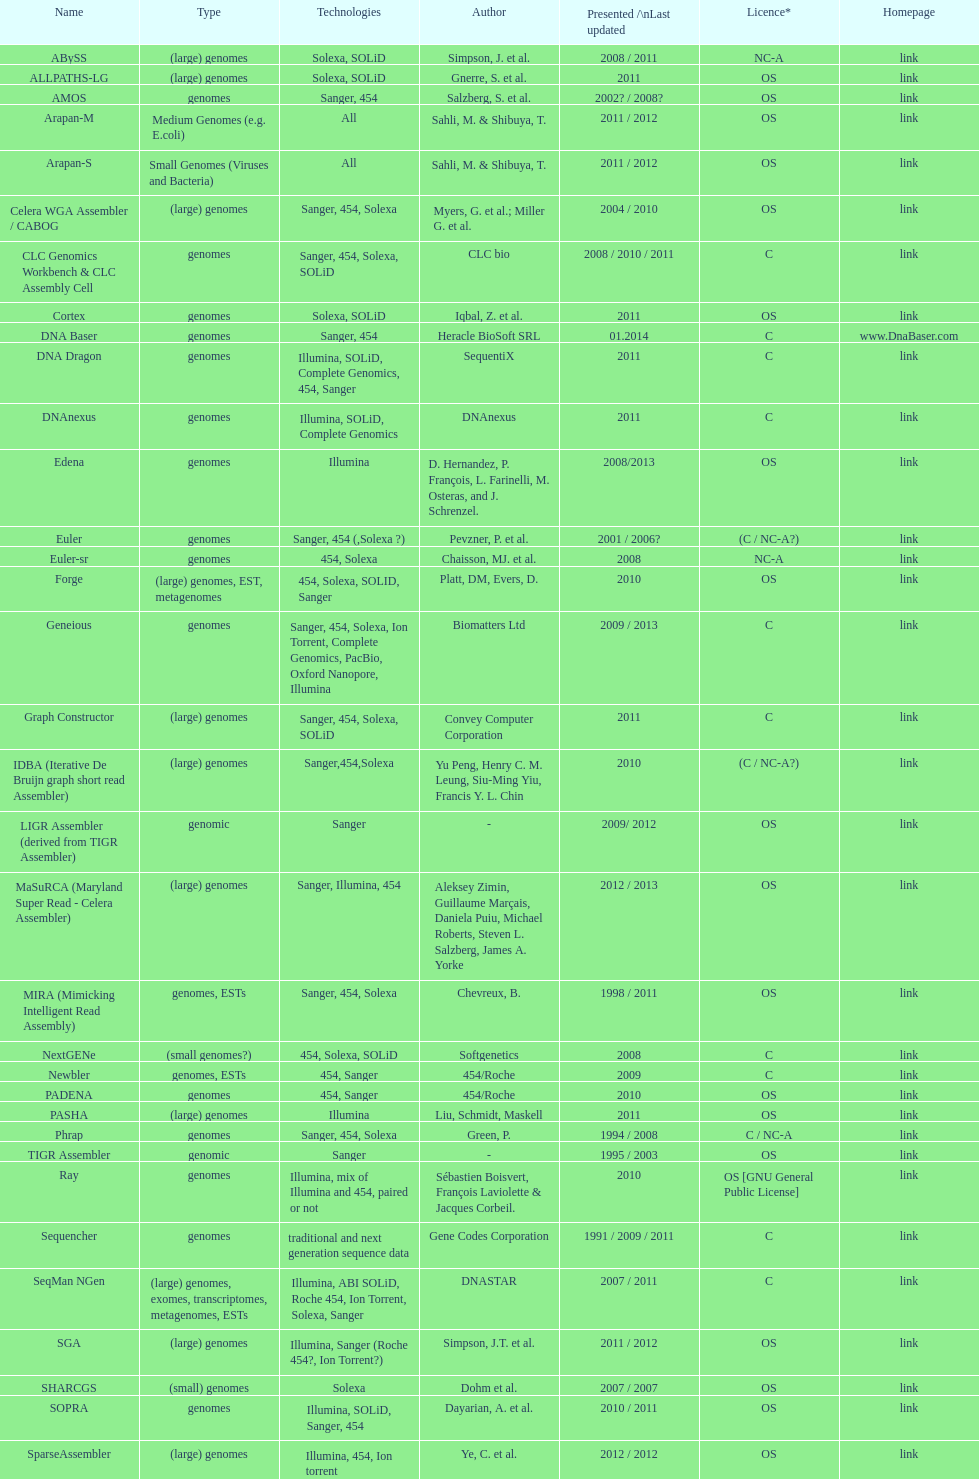How many assemblers are compatible with medium genome type technologies? 1. 